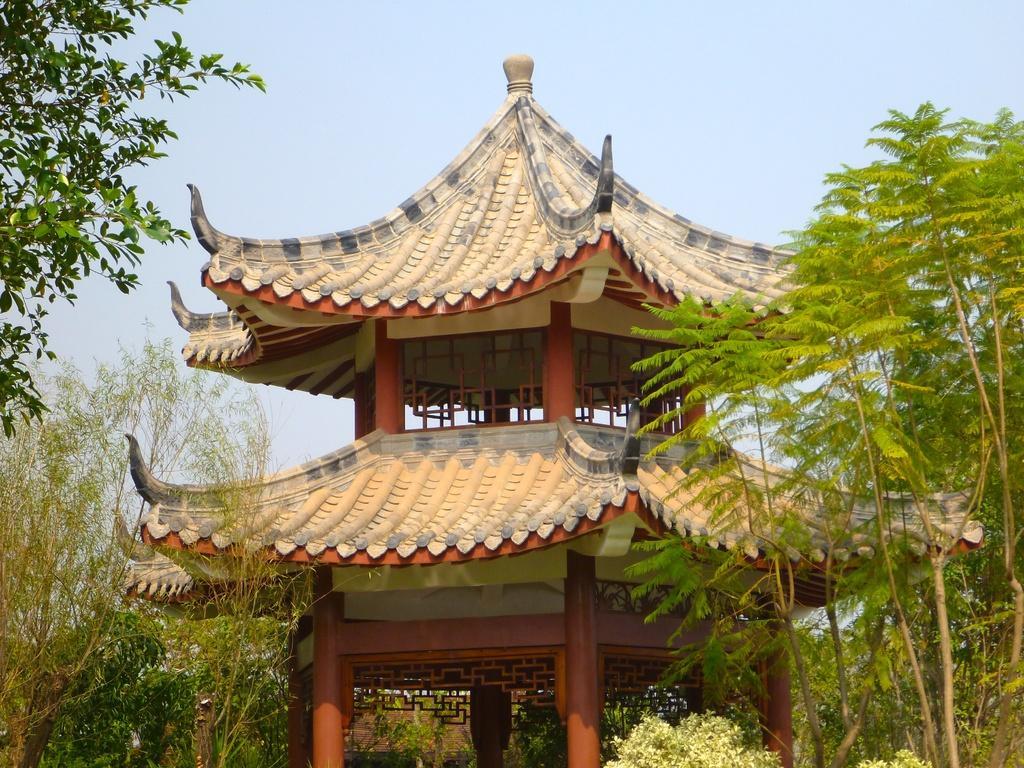Describe this image in one or two sentences. In the middle it is a construction and these are the trees. At the top it's a sky. 